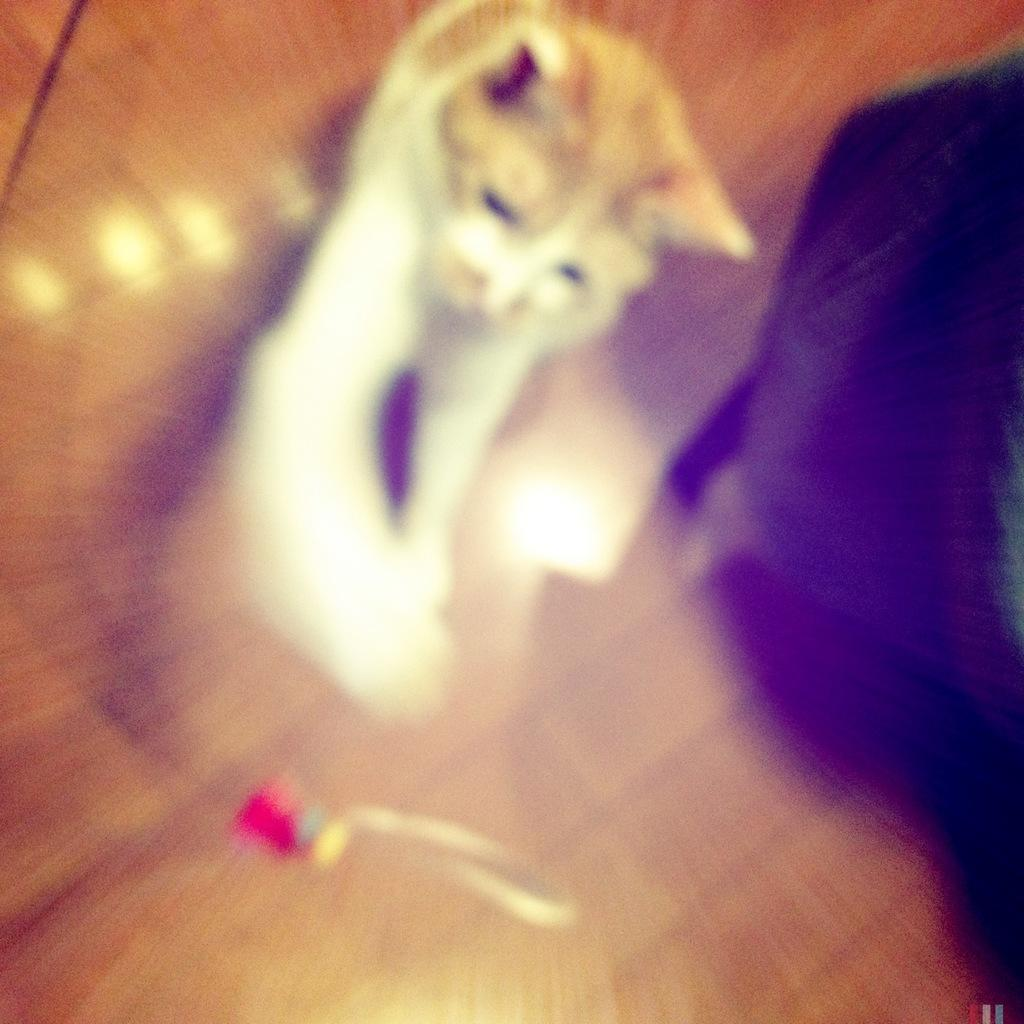What type of animal is in the image? There is a white color cat in the image. Where is the cat located in the image? The cat is under a table. What is the table made of? The table is made up of glass. What can be seen on the right side of the image? There is a black color object on the right side of the image. What type of prose is the cat reading on the desk in the image? There is no desk or prose present in the image; it features a white color cat under a glass table and a black color object on the right side. 